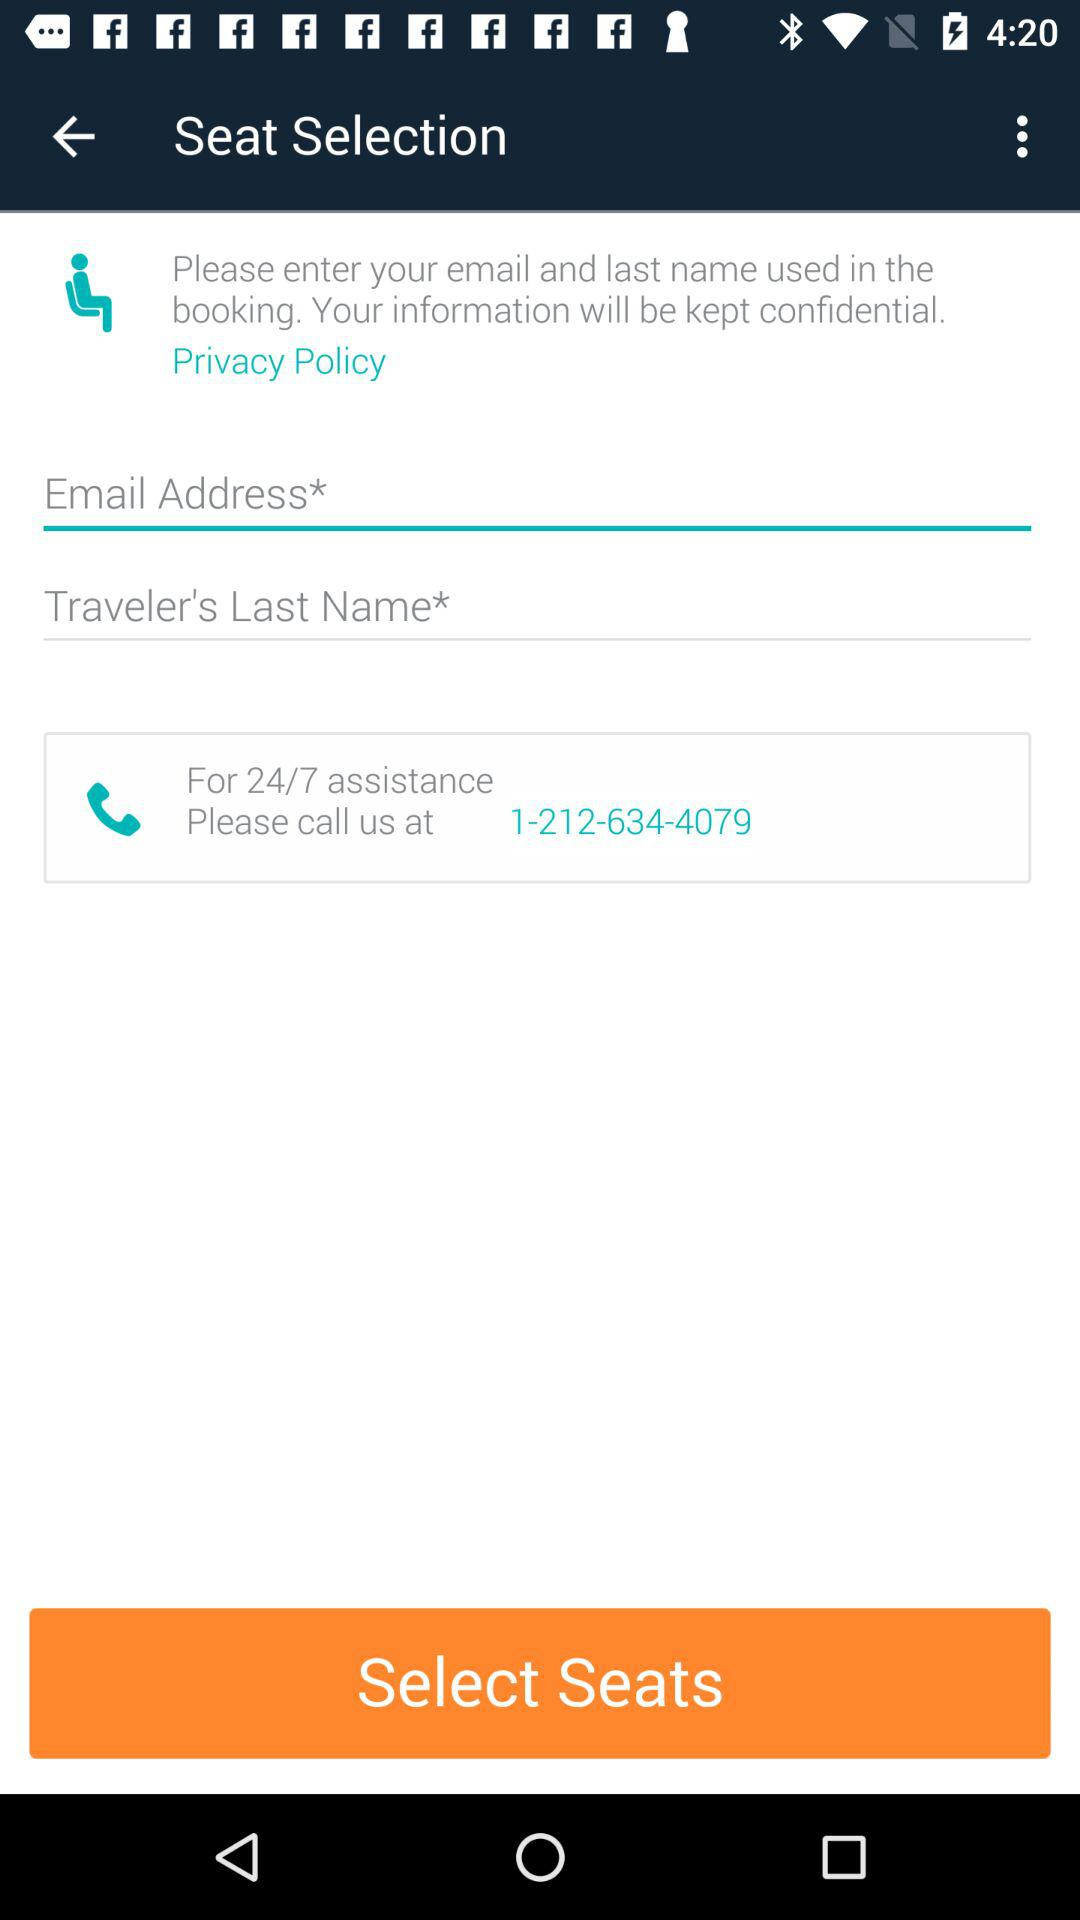What options are provided for assistance? The image displays a phone number for 24/7 assistance, indicating that users can call at any time if they need help. 